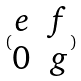<formula> <loc_0><loc_0><loc_500><loc_500>( \begin{matrix} e & f \\ 0 & g \end{matrix} )</formula> 